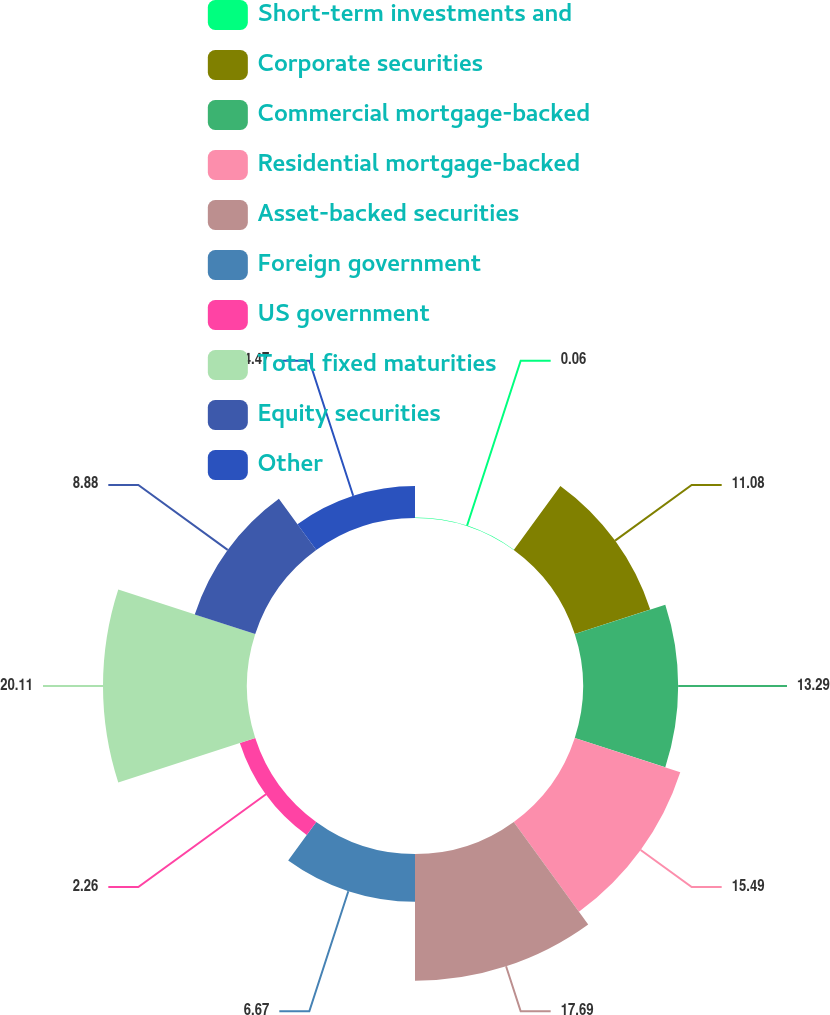Convert chart to OTSL. <chart><loc_0><loc_0><loc_500><loc_500><pie_chart><fcel>Short-term investments and<fcel>Corporate securities<fcel>Commercial mortgage-backed<fcel>Residential mortgage-backed<fcel>Asset-backed securities<fcel>Foreign government<fcel>US government<fcel>Total fixed maturities<fcel>Equity securities<fcel>Other<nl><fcel>0.06%<fcel>11.08%<fcel>13.29%<fcel>15.49%<fcel>17.69%<fcel>6.67%<fcel>2.26%<fcel>20.11%<fcel>8.88%<fcel>4.47%<nl></chart> 